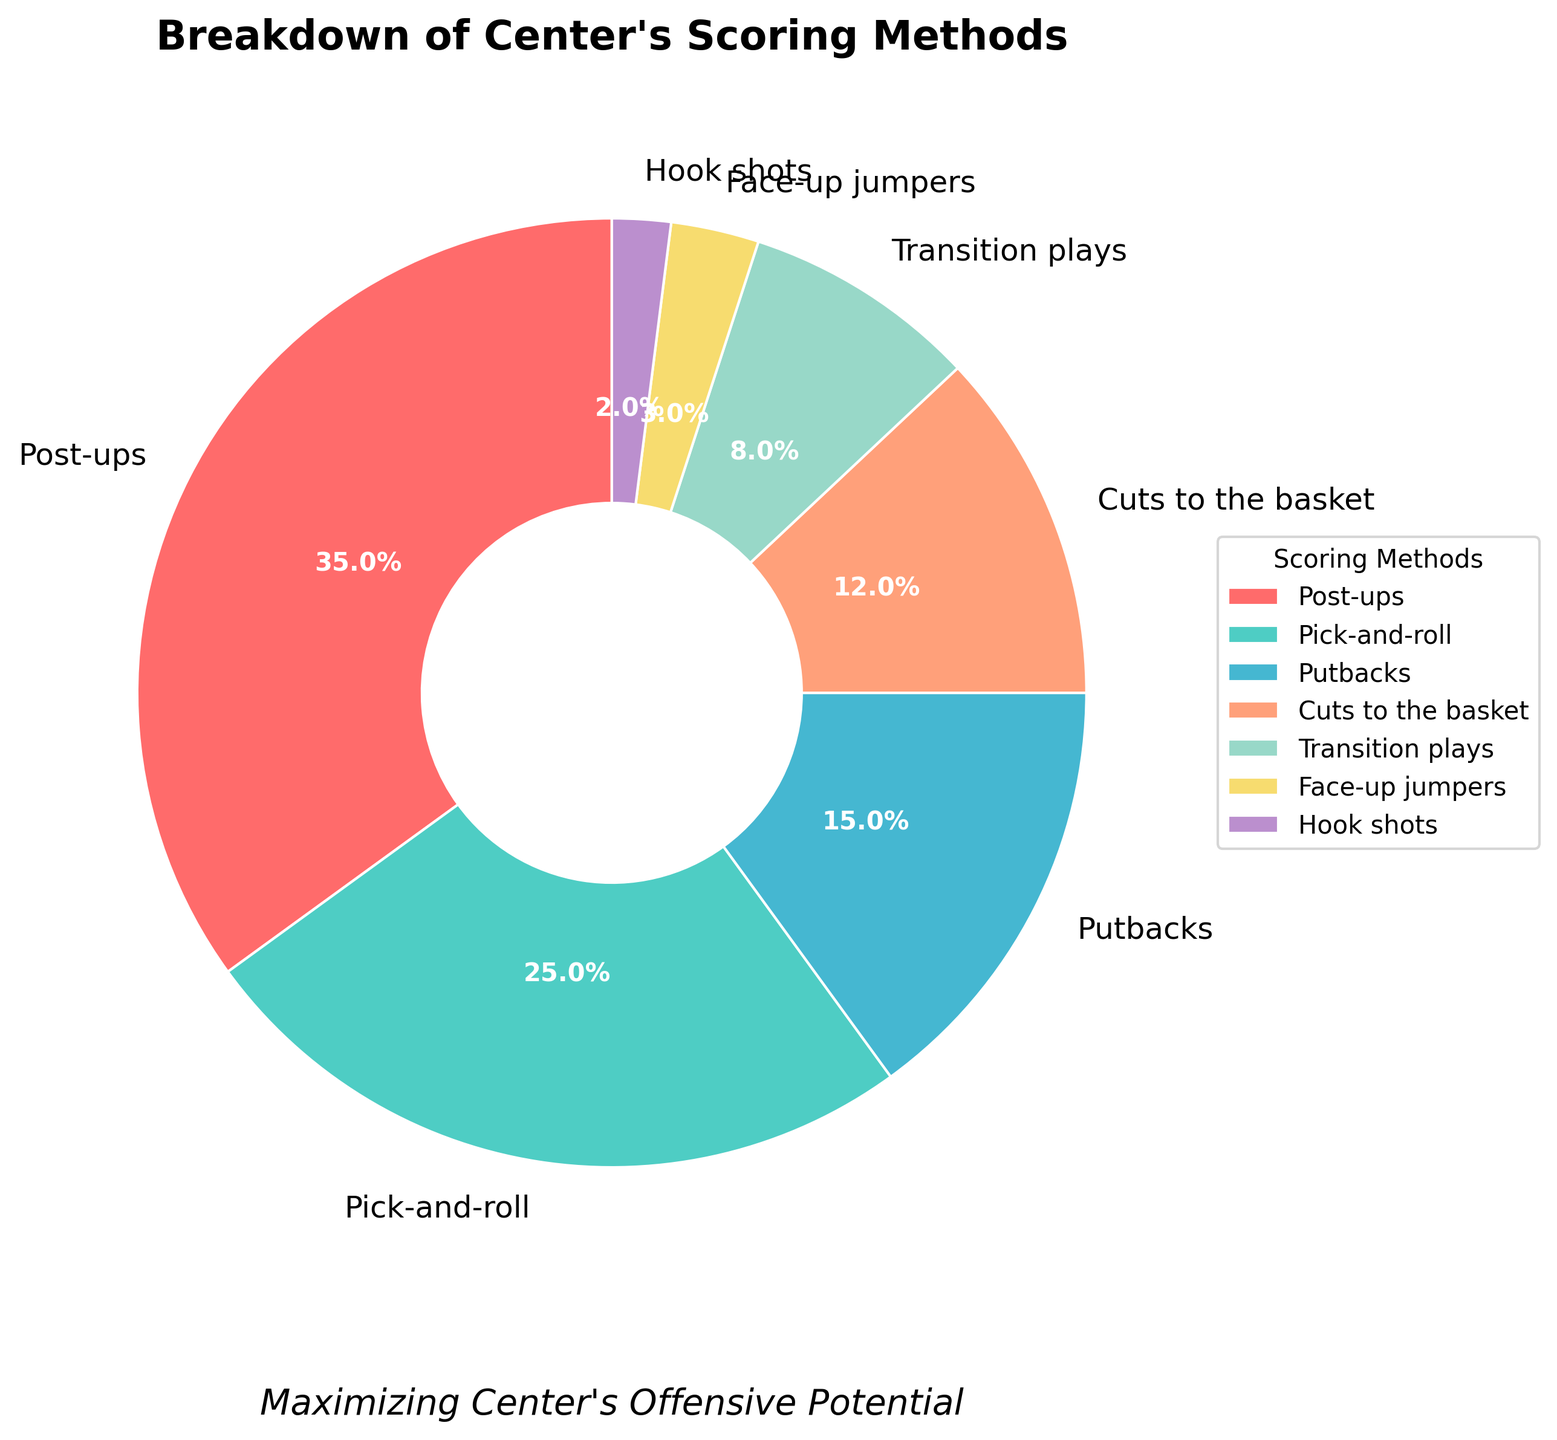What percentage of the center's scoring comes from transitions and face-up jumpers combined? To find the combined percentage, add the individual percentages of transition plays and face-up jumpers. Transition plays account for 8% and face-up jumpers account for 3%. Therefore, the combined percentage is 8% + 3% = 11%.
Answer: 11% Which scoring method has the second-highest percentage? By observing the pie chart, we see that the method with the highest percentage is post-ups at 35%. The next highest percentage is pick-and-roll at 25%.
Answer: Pick-and-roll Are putbacks more or less frequent than cuts to the basket? To determine the frequency comparison, look at the percentages for putbacks and cuts to the basket. Putbacks account for 15% while cuts to the basket account for 12%. 15% is greater than 12%, so putbacks are more frequent.
Answer: More frequent What is the difference in percentage between post-ups and pick-and-roll? To find the difference, subtract the percentage of pick-and-roll from the percentage of post-ups. Post-ups are 35% and pick-and-roll is 25%, so the difference is 35% - 25% = 10%.
Answer: 10% What percentage of the center's scoring comes from methods other than post-ups and pick-and-roll? To find the percentage from other methods, subtract the percentages of post-ups and pick-and-roll from 100%. Post-ups account for 35% and pick-and-roll account for 25%. The combined percentage of these two methods is 35% + 25% = 60%. Thus, 100% - 60% = 40% comes from methods other than post-ups and pick-and-roll.
Answer: 40% If the center were to score 100 points, how many points would come from post-ups? To find the points from post-ups, use the percentage of scoring from post-ups, which is 35%. Therefore, from 100 points, the points from post-ups would be 35% of 100, which is 0.35 * 100 = 35 points.
Answer: 35 points Which scoring methods combined make up less than 10% of the total scoring? Observing the pie chart, we note that face-up jumpers (3%) and hook shots (2%) have individual percentages less than 10%. Combined, they constitute 3% + 2% = 5%, which is less than 10%.
Answer: Face-up jumpers and hook shots 